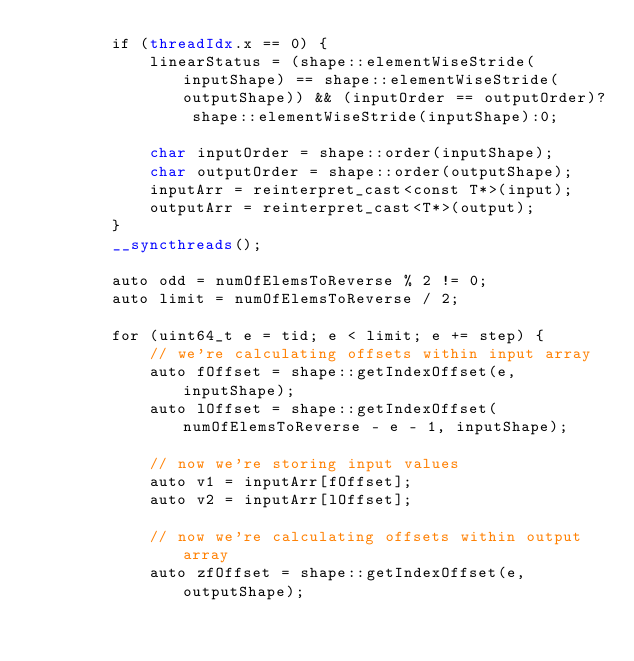<code> <loc_0><loc_0><loc_500><loc_500><_Cuda_>        if (threadIdx.x == 0) {
            linearStatus = (shape::elementWiseStride(inputShape) == shape::elementWiseStride(outputShape)) && (inputOrder == outputOrder)? shape::elementWiseStride(inputShape):0;

            char inputOrder = shape::order(inputShape);
            char outputOrder = shape::order(outputShape);
            inputArr = reinterpret_cast<const T*>(input);
            outputArr = reinterpret_cast<T*>(output);
        }
        __syncthreads();

        auto odd = numOfElemsToReverse % 2 != 0;
        auto limit = numOfElemsToReverse / 2;

        for (uint64_t e = tid; e < limit; e += step) {
            // we're calculating offsets within input array
            auto fOffset = shape::getIndexOffset(e, inputShape);
            auto lOffset = shape::getIndexOffset(numOfElemsToReverse - e - 1, inputShape);

            // now we're storing input values
            auto v1 = inputArr[fOffset];
            auto v2 = inputArr[lOffset];

            // now we're calculating offsets within output array
            auto zfOffset = shape::getIndexOffset(e, outputShape);</code> 